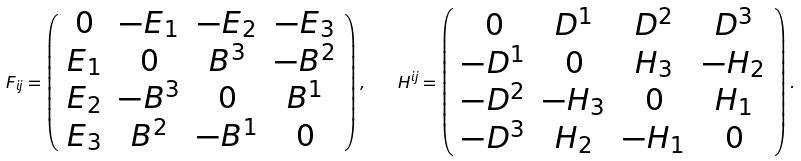<formula> <loc_0><loc_0><loc_500><loc_500>F _ { i j } = \left ( \begin{array} { c c c c } 0 & - E _ { 1 } & - E _ { 2 } & - E _ { 3 } \\ E _ { 1 } & 0 & B ^ { 3 } & - B ^ { 2 } \\ E _ { 2 } & - B ^ { 3 } & 0 & B ^ { 1 } \\ E _ { 3 } & B ^ { 2 } & - B ^ { 1 } & 0 \end{array} \right ) , \quad H ^ { i j } = \left ( \begin{array} { c c c c } 0 & D ^ { 1 } & D ^ { 2 } & D ^ { 3 } \\ - D ^ { 1 } & 0 & H _ { 3 } & - H _ { 2 } \\ - D ^ { 2 } & - H _ { 3 } & 0 & H _ { 1 } \\ - D ^ { 3 } & H _ { 2 } & - H _ { 1 } & 0 \end{array} \right ) .</formula> 